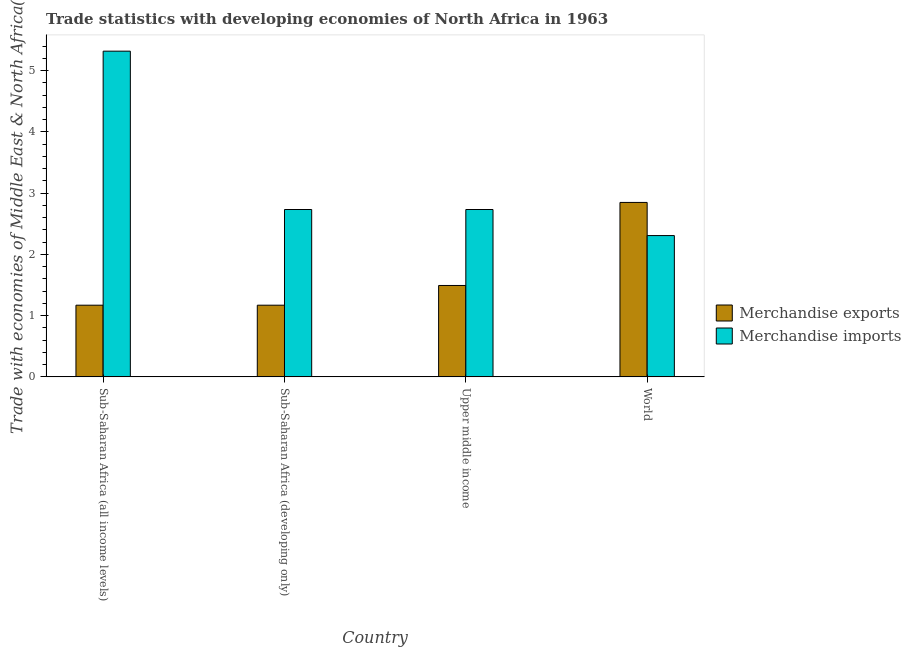How many different coloured bars are there?
Keep it short and to the point. 2. How many bars are there on the 2nd tick from the right?
Keep it short and to the point. 2. What is the label of the 1st group of bars from the left?
Provide a short and direct response. Sub-Saharan Africa (all income levels). What is the merchandise exports in Upper middle income?
Give a very brief answer. 1.49. Across all countries, what is the maximum merchandise imports?
Your answer should be very brief. 5.32. Across all countries, what is the minimum merchandise exports?
Give a very brief answer. 1.17. What is the total merchandise exports in the graph?
Provide a succinct answer. 6.68. What is the difference between the merchandise exports in Sub-Saharan Africa (all income levels) and that in Upper middle income?
Provide a short and direct response. -0.32. What is the difference between the merchandise imports in Sub-Saharan Africa (developing only) and the merchandise exports in World?
Keep it short and to the point. -0.12. What is the average merchandise exports per country?
Provide a succinct answer. 1.67. What is the difference between the merchandise imports and merchandise exports in Upper middle income?
Offer a very short reply. 1.24. What is the ratio of the merchandise imports in Sub-Saharan Africa (developing only) to that in World?
Make the answer very short. 1.18. Is the difference between the merchandise exports in Sub-Saharan Africa (developing only) and Upper middle income greater than the difference between the merchandise imports in Sub-Saharan Africa (developing only) and Upper middle income?
Offer a terse response. No. What is the difference between the highest and the second highest merchandise imports?
Provide a succinct answer. 2.59. What is the difference between the highest and the lowest merchandise imports?
Give a very brief answer. 3.01. Is the sum of the merchandise imports in Upper middle income and World greater than the maximum merchandise exports across all countries?
Give a very brief answer. Yes. What is the difference between two consecutive major ticks on the Y-axis?
Provide a short and direct response. 1. Where does the legend appear in the graph?
Offer a very short reply. Center right. How are the legend labels stacked?
Offer a terse response. Vertical. What is the title of the graph?
Your answer should be very brief. Trade statistics with developing economies of North Africa in 1963. Does "Borrowers" appear as one of the legend labels in the graph?
Ensure brevity in your answer.  No. What is the label or title of the X-axis?
Give a very brief answer. Country. What is the label or title of the Y-axis?
Your answer should be compact. Trade with economies of Middle East & North Africa(%). What is the Trade with economies of Middle East & North Africa(%) of Merchandise exports in Sub-Saharan Africa (all income levels)?
Your response must be concise. 1.17. What is the Trade with economies of Middle East & North Africa(%) of Merchandise imports in Sub-Saharan Africa (all income levels)?
Make the answer very short. 5.32. What is the Trade with economies of Middle East & North Africa(%) in Merchandise exports in Sub-Saharan Africa (developing only)?
Your response must be concise. 1.17. What is the Trade with economies of Middle East & North Africa(%) in Merchandise imports in Sub-Saharan Africa (developing only)?
Offer a very short reply. 2.73. What is the Trade with economies of Middle East & North Africa(%) in Merchandise exports in Upper middle income?
Your response must be concise. 1.49. What is the Trade with economies of Middle East & North Africa(%) in Merchandise imports in Upper middle income?
Provide a short and direct response. 2.73. What is the Trade with economies of Middle East & North Africa(%) of Merchandise exports in World?
Offer a terse response. 2.85. What is the Trade with economies of Middle East & North Africa(%) in Merchandise imports in World?
Provide a short and direct response. 2.31. Across all countries, what is the maximum Trade with economies of Middle East & North Africa(%) in Merchandise exports?
Provide a succinct answer. 2.85. Across all countries, what is the maximum Trade with economies of Middle East & North Africa(%) of Merchandise imports?
Your response must be concise. 5.32. Across all countries, what is the minimum Trade with economies of Middle East & North Africa(%) in Merchandise exports?
Your response must be concise. 1.17. Across all countries, what is the minimum Trade with economies of Middle East & North Africa(%) in Merchandise imports?
Give a very brief answer. 2.31. What is the total Trade with economies of Middle East & North Africa(%) of Merchandise exports in the graph?
Provide a short and direct response. 6.68. What is the total Trade with economies of Middle East & North Africa(%) in Merchandise imports in the graph?
Your answer should be compact. 13.09. What is the difference between the Trade with economies of Middle East & North Africa(%) in Merchandise imports in Sub-Saharan Africa (all income levels) and that in Sub-Saharan Africa (developing only)?
Give a very brief answer. 2.59. What is the difference between the Trade with economies of Middle East & North Africa(%) of Merchandise exports in Sub-Saharan Africa (all income levels) and that in Upper middle income?
Your answer should be very brief. -0.32. What is the difference between the Trade with economies of Middle East & North Africa(%) in Merchandise imports in Sub-Saharan Africa (all income levels) and that in Upper middle income?
Provide a short and direct response. 2.59. What is the difference between the Trade with economies of Middle East & North Africa(%) of Merchandise exports in Sub-Saharan Africa (all income levels) and that in World?
Provide a succinct answer. -1.68. What is the difference between the Trade with economies of Middle East & North Africa(%) of Merchandise imports in Sub-Saharan Africa (all income levels) and that in World?
Provide a short and direct response. 3.01. What is the difference between the Trade with economies of Middle East & North Africa(%) of Merchandise exports in Sub-Saharan Africa (developing only) and that in Upper middle income?
Keep it short and to the point. -0.32. What is the difference between the Trade with economies of Middle East & North Africa(%) of Merchandise exports in Sub-Saharan Africa (developing only) and that in World?
Ensure brevity in your answer.  -1.68. What is the difference between the Trade with economies of Middle East & North Africa(%) of Merchandise imports in Sub-Saharan Africa (developing only) and that in World?
Your response must be concise. 0.43. What is the difference between the Trade with economies of Middle East & North Africa(%) of Merchandise exports in Upper middle income and that in World?
Offer a terse response. -1.36. What is the difference between the Trade with economies of Middle East & North Africa(%) of Merchandise imports in Upper middle income and that in World?
Give a very brief answer. 0.43. What is the difference between the Trade with economies of Middle East & North Africa(%) in Merchandise exports in Sub-Saharan Africa (all income levels) and the Trade with economies of Middle East & North Africa(%) in Merchandise imports in Sub-Saharan Africa (developing only)?
Give a very brief answer. -1.56. What is the difference between the Trade with economies of Middle East & North Africa(%) of Merchandise exports in Sub-Saharan Africa (all income levels) and the Trade with economies of Middle East & North Africa(%) of Merchandise imports in Upper middle income?
Ensure brevity in your answer.  -1.56. What is the difference between the Trade with economies of Middle East & North Africa(%) in Merchandise exports in Sub-Saharan Africa (all income levels) and the Trade with economies of Middle East & North Africa(%) in Merchandise imports in World?
Your response must be concise. -1.14. What is the difference between the Trade with economies of Middle East & North Africa(%) in Merchandise exports in Sub-Saharan Africa (developing only) and the Trade with economies of Middle East & North Africa(%) in Merchandise imports in Upper middle income?
Ensure brevity in your answer.  -1.56. What is the difference between the Trade with economies of Middle East & North Africa(%) in Merchandise exports in Sub-Saharan Africa (developing only) and the Trade with economies of Middle East & North Africa(%) in Merchandise imports in World?
Your answer should be very brief. -1.14. What is the difference between the Trade with economies of Middle East & North Africa(%) in Merchandise exports in Upper middle income and the Trade with economies of Middle East & North Africa(%) in Merchandise imports in World?
Your response must be concise. -0.81. What is the average Trade with economies of Middle East & North Africa(%) in Merchandise exports per country?
Offer a very short reply. 1.67. What is the average Trade with economies of Middle East & North Africa(%) in Merchandise imports per country?
Offer a very short reply. 3.27. What is the difference between the Trade with economies of Middle East & North Africa(%) in Merchandise exports and Trade with economies of Middle East & North Africa(%) in Merchandise imports in Sub-Saharan Africa (all income levels)?
Offer a very short reply. -4.15. What is the difference between the Trade with economies of Middle East & North Africa(%) in Merchandise exports and Trade with economies of Middle East & North Africa(%) in Merchandise imports in Sub-Saharan Africa (developing only)?
Ensure brevity in your answer.  -1.56. What is the difference between the Trade with economies of Middle East & North Africa(%) of Merchandise exports and Trade with economies of Middle East & North Africa(%) of Merchandise imports in Upper middle income?
Make the answer very short. -1.24. What is the difference between the Trade with economies of Middle East & North Africa(%) in Merchandise exports and Trade with economies of Middle East & North Africa(%) in Merchandise imports in World?
Provide a succinct answer. 0.54. What is the ratio of the Trade with economies of Middle East & North Africa(%) of Merchandise imports in Sub-Saharan Africa (all income levels) to that in Sub-Saharan Africa (developing only)?
Ensure brevity in your answer.  1.95. What is the ratio of the Trade with economies of Middle East & North Africa(%) in Merchandise exports in Sub-Saharan Africa (all income levels) to that in Upper middle income?
Your answer should be very brief. 0.78. What is the ratio of the Trade with economies of Middle East & North Africa(%) of Merchandise imports in Sub-Saharan Africa (all income levels) to that in Upper middle income?
Give a very brief answer. 1.95. What is the ratio of the Trade with economies of Middle East & North Africa(%) of Merchandise exports in Sub-Saharan Africa (all income levels) to that in World?
Your response must be concise. 0.41. What is the ratio of the Trade with economies of Middle East & North Africa(%) of Merchandise imports in Sub-Saharan Africa (all income levels) to that in World?
Provide a short and direct response. 2.31. What is the ratio of the Trade with economies of Middle East & North Africa(%) in Merchandise exports in Sub-Saharan Africa (developing only) to that in Upper middle income?
Offer a terse response. 0.78. What is the ratio of the Trade with economies of Middle East & North Africa(%) in Merchandise imports in Sub-Saharan Africa (developing only) to that in Upper middle income?
Provide a short and direct response. 1. What is the ratio of the Trade with economies of Middle East & North Africa(%) of Merchandise exports in Sub-Saharan Africa (developing only) to that in World?
Give a very brief answer. 0.41. What is the ratio of the Trade with economies of Middle East & North Africa(%) in Merchandise imports in Sub-Saharan Africa (developing only) to that in World?
Give a very brief answer. 1.18. What is the ratio of the Trade with economies of Middle East & North Africa(%) in Merchandise exports in Upper middle income to that in World?
Make the answer very short. 0.52. What is the ratio of the Trade with economies of Middle East & North Africa(%) of Merchandise imports in Upper middle income to that in World?
Your answer should be compact. 1.18. What is the difference between the highest and the second highest Trade with economies of Middle East & North Africa(%) in Merchandise exports?
Your answer should be compact. 1.36. What is the difference between the highest and the second highest Trade with economies of Middle East & North Africa(%) of Merchandise imports?
Make the answer very short. 2.59. What is the difference between the highest and the lowest Trade with economies of Middle East & North Africa(%) of Merchandise exports?
Provide a short and direct response. 1.68. What is the difference between the highest and the lowest Trade with economies of Middle East & North Africa(%) in Merchandise imports?
Offer a terse response. 3.01. 